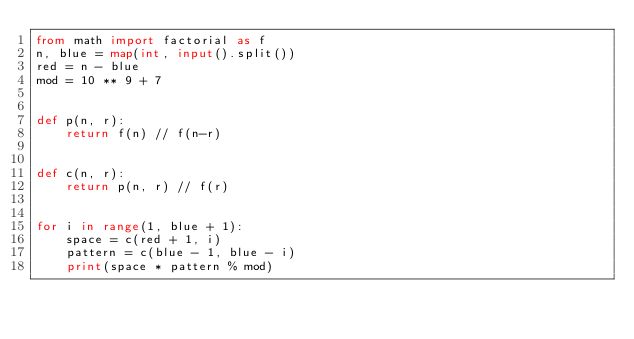Convert code to text. <code><loc_0><loc_0><loc_500><loc_500><_Python_>from math import factorial as f
n, blue = map(int, input().split())
red = n - blue
mod = 10 ** 9 + 7


def p(n, r):
    return f(n) // f(n-r)


def c(n, r):
    return p(n, r) // f(r)


for i in range(1, blue + 1):
    space = c(red + 1, i)
    pattern = c(blue - 1, blue - i)
    print(space * pattern % mod)
</code> 